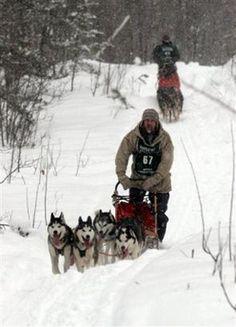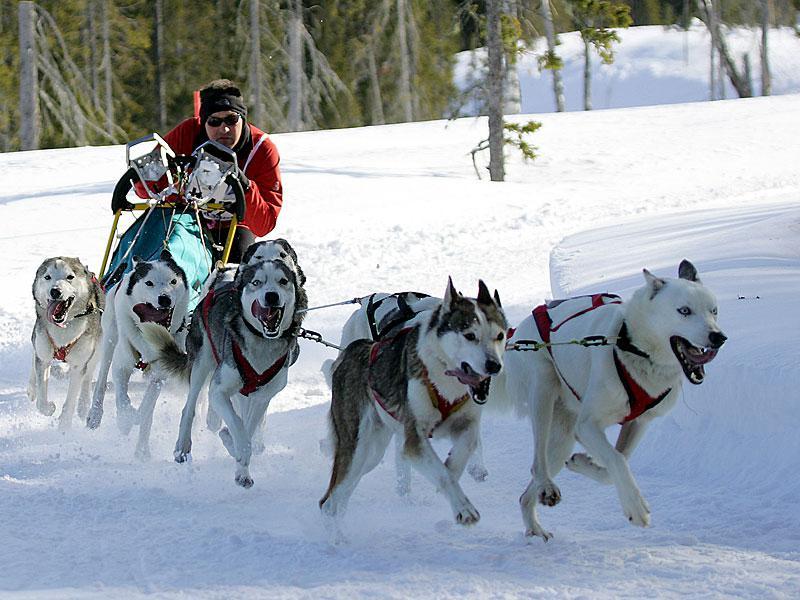The first image is the image on the left, the second image is the image on the right. Given the left and right images, does the statement "There are at least two people riding on one of the dog sleds." hold true? Answer yes or no. No. The first image is the image on the left, the second image is the image on the right. Assess this claim about the two images: "the right image has humans in red jackets". Correct or not? Answer yes or no. Yes. 